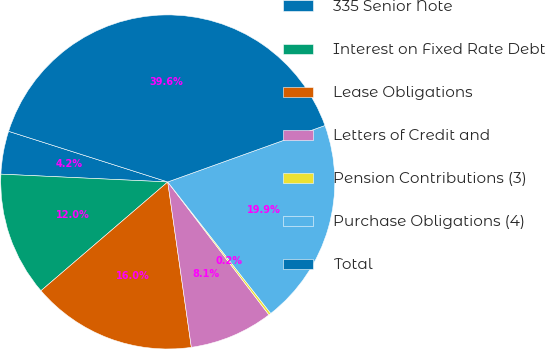Convert chart to OTSL. <chart><loc_0><loc_0><loc_500><loc_500><pie_chart><fcel>335 Senior Note<fcel>Interest on Fixed Rate Debt<fcel>Lease Obligations<fcel>Letters of Credit and<fcel>Pension Contributions (3)<fcel>Purchase Obligations (4)<fcel>Total<nl><fcel>4.16%<fcel>12.03%<fcel>15.97%<fcel>8.1%<fcel>0.22%<fcel>19.91%<fcel>39.61%<nl></chart> 